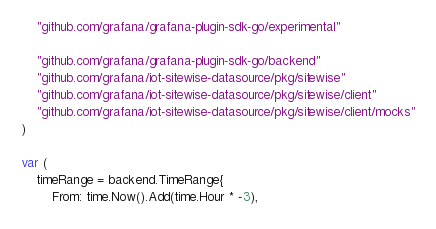<code> <loc_0><loc_0><loc_500><loc_500><_Go_>
	"github.com/grafana/grafana-plugin-sdk-go/experimental"

	"github.com/grafana/grafana-plugin-sdk-go/backend"
	"github.com/grafana/iot-sitewise-datasource/pkg/sitewise"
	"github.com/grafana/iot-sitewise-datasource/pkg/sitewise/client"
	"github.com/grafana/iot-sitewise-datasource/pkg/sitewise/client/mocks"
)

var (
	timeRange = backend.TimeRange{
		From: time.Now().Add(time.Hour * -3),</code> 